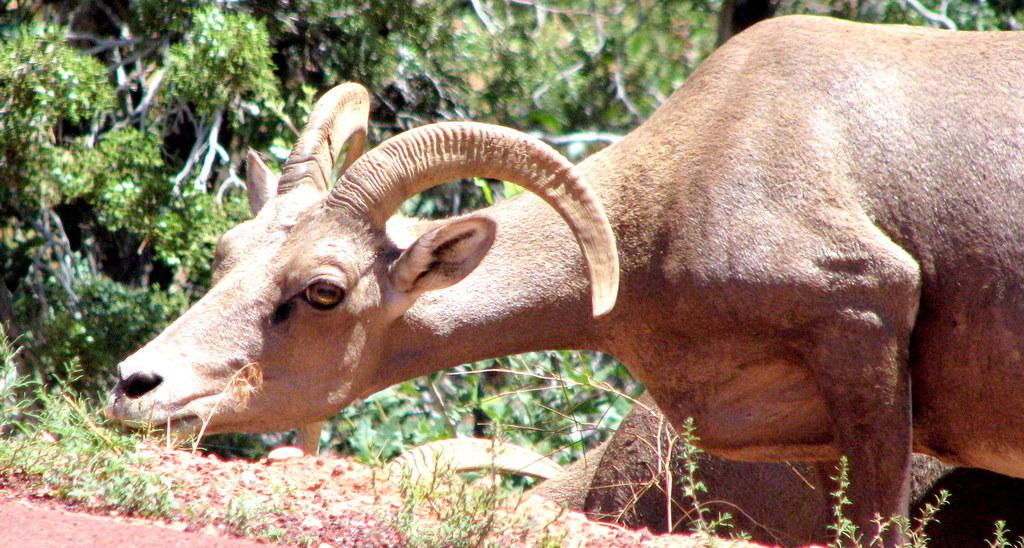What type of vegetation is present in the image? There are many trees and plants in the image. Can you describe the animals in the image? There are few animals in the image. What type of light source is illuminating the image? There is no specific light source mentioned in the image, as it appears to be a natural scene with sunlight or ambient light. Can you see a crib in the image? There is: There is no crib present in the image. 